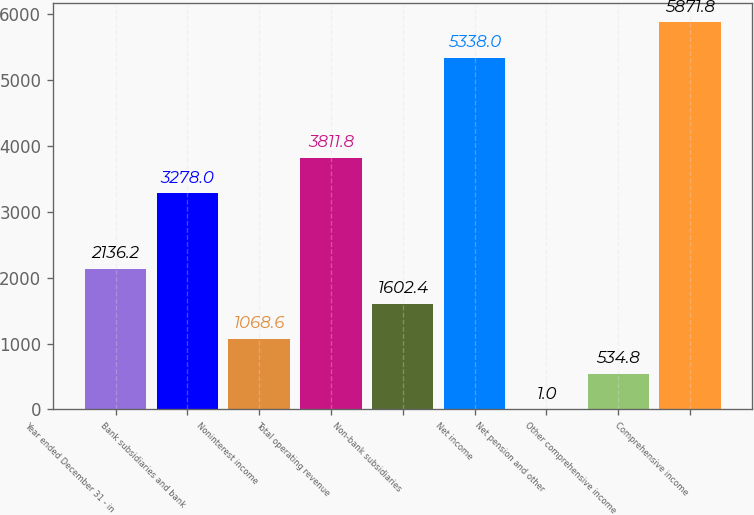Convert chart. <chart><loc_0><loc_0><loc_500><loc_500><bar_chart><fcel>Year ended December 31 - in<fcel>Bank subsidiaries and bank<fcel>Noninterest income<fcel>Total operating revenue<fcel>Non-bank subsidiaries<fcel>Net income<fcel>Net pension and other<fcel>Other comprehensive income<fcel>Comprehensive income<nl><fcel>2136.2<fcel>3278<fcel>1068.6<fcel>3811.8<fcel>1602.4<fcel>5338<fcel>1<fcel>534.8<fcel>5871.8<nl></chart> 